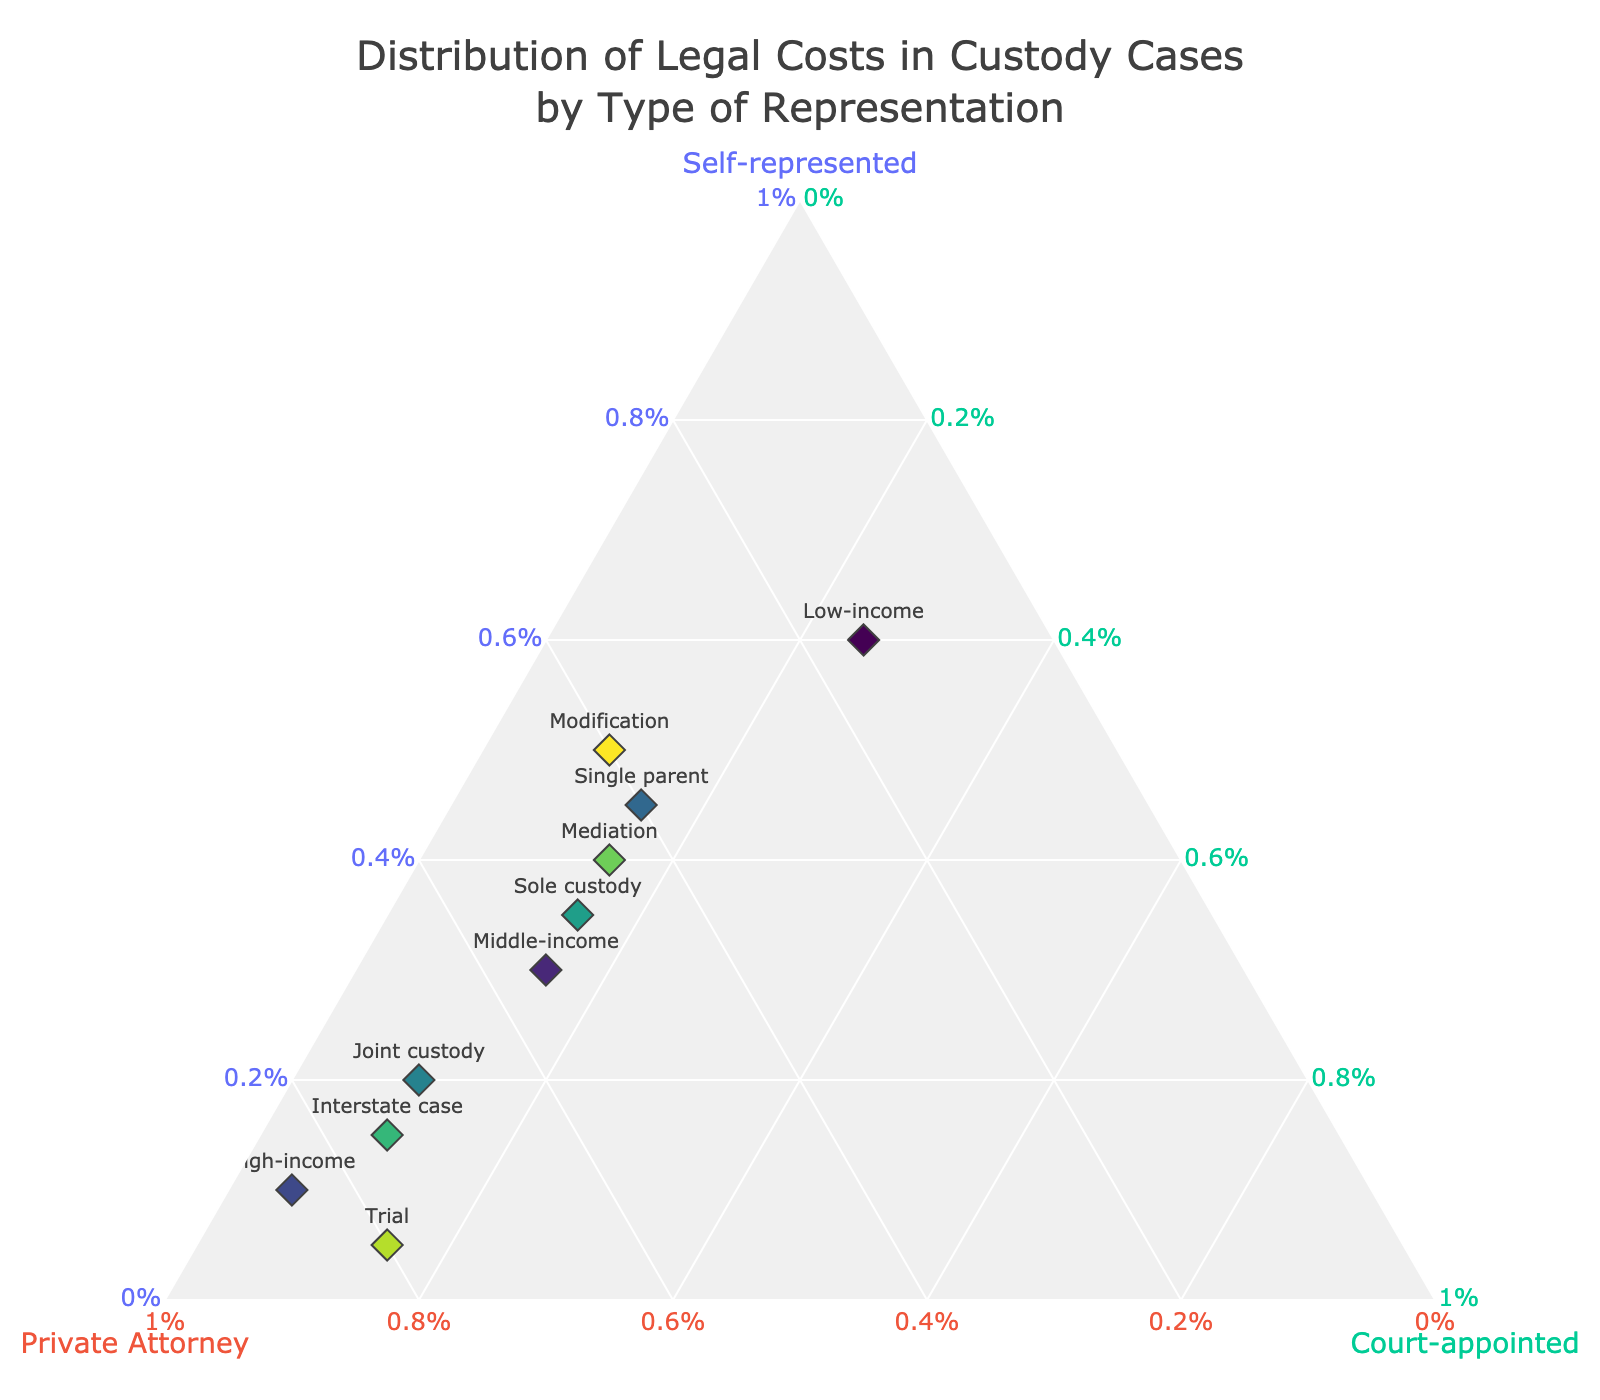what is the title of the plot? The title is usually displayed prominently at the top of the plot. Reading the top section of the plot shows the title is "Distribution of Legal Costs in Custody Cases by Type of Representation".
Answer: Distribution of Legal Costs in Custody Cases by Type of Representation How many types of custody cases are shown in the plot? Each data point corresponds to a specific type of custody case. By counting the number of labels, we can determine the total number of types. The plot has 10 different labels corresponding to types of custody cases.
Answer: 10 Which type of custody case has the highest proportion of private attorney representation? Look for the data point closest to the apex of the 'Private Attorney' axis, which is on the right side of the ternary plot. "High-income" is the type closest to the Private Attorney apex with 85% representation.
Answer: High-income What is the proportion of self-representation for Low-income cases? Find the label "Low-income" and check its value on the Self-represented axis. The value is 60%.
Answer: 60% Which type of custody case has equal proportions of private attorney and court-appointed representation? Identify the data points where the values for Private Attorney and Court-appointed representation are equal. "Sole custody" has both private attorney and court-appointed at 50% and 15%, respectively, which does not match. No such type exists.
Answer: None Which type has the lowest proportion of self-representation? Look for the data point closest to the 'Private Attorney' and 'Court-appointed' apexes, far from the 'Self-represented' apex. "Trial" is the closest, with self-representation at 5%.
Answer: Trial What is the difference in the proportion of self-represented cases between Joint custody and Sole custody? Subtract the self-represented proportion of Joint custody (20%) from that of Sole custody (35%). The difference is 35% - 20% = 15%.
Answer: 15% Which type of case has a moderate level (around 50%) of representation by private attorneys? Scan the plot for cases where the Private Attorney proportion is near 50%. "Middle-income" and "Sole custody" each have 55% and 50% private attorney representation, respectively.
Answer: Middle-income and Sole custody For Modification cases, what is the sum of the proportions of self-representation and court-appointed representation? Add the values for self-representation and court-appointed representation for Modification cases. 50% (self-representation) + 10% (court-appointed) = 60%.
Answer: 60% In which type of court case does court-appointed representation exceed self-representation? Scan points where the Court-appointed value is greater than the Self-represented value. No such point has a higher court-appointed proportion than self-represented.
Answer: None 